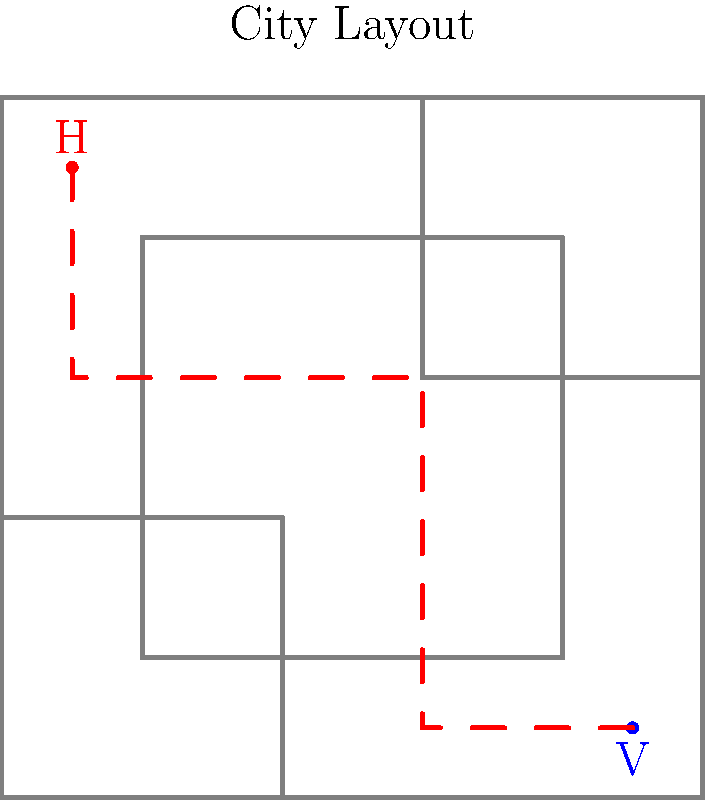In the maze-like city layout shown above, where "H" represents the human stronghold and "V" represents the vampire stronghold, what is the minimum number of street segments that must be traversed to reach the vampire stronghold from the human stronghold? To find the shortest path between the human and vampire strongholds, we need to analyze the city layout and identify the route with the fewest street segments. Let's break it down step-by-step:

1. Start at the human stronghold (H) in the top-left corner.
2. Move south along the left edge of the city until reaching the horizontal corridor at y=60.
3. Turn right and move east along this corridor until reaching the vertical corridor at x=60.
4. Turn south and follow this corridor down to y=10.
5. Finally, turn east and move to the vampire stronghold (V) in the bottom-right corner.

Counting the street segments traversed:
1. H to (10,60): 1 segment
2. (10,60) to (60,60): 1 segment
3. (60,60) to (60,10): 1 segment
4. (60,10) to V: 1 segment

The total number of street segments traversed is 4.

This path avoids all obstacles and uses the available corridors to minimize the number of turns and total distance traveled.
Answer: 4 segments 